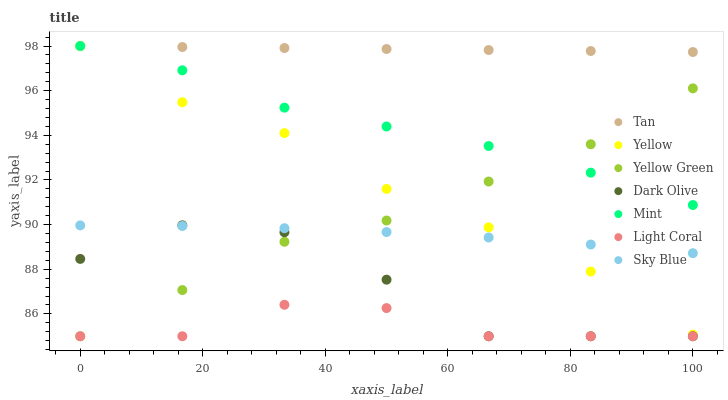Does Light Coral have the minimum area under the curve?
Answer yes or no. Yes. Does Tan have the maximum area under the curve?
Answer yes or no. Yes. Does Dark Olive have the minimum area under the curve?
Answer yes or no. No. Does Dark Olive have the maximum area under the curve?
Answer yes or no. No. Is Tan the smoothest?
Answer yes or no. Yes. Is Dark Olive the roughest?
Answer yes or no. Yes. Is Yellow the smoothest?
Answer yes or no. No. Is Yellow the roughest?
Answer yes or no. No. Does Yellow Green have the lowest value?
Answer yes or no. Yes. Does Yellow have the lowest value?
Answer yes or no. No. Does Mint have the highest value?
Answer yes or no. Yes. Does Dark Olive have the highest value?
Answer yes or no. No. Is Sky Blue less than Mint?
Answer yes or no. Yes. Is Sky Blue greater than Light Coral?
Answer yes or no. Yes. Does Mint intersect Tan?
Answer yes or no. Yes. Is Mint less than Tan?
Answer yes or no. No. Is Mint greater than Tan?
Answer yes or no. No. Does Sky Blue intersect Mint?
Answer yes or no. No. 